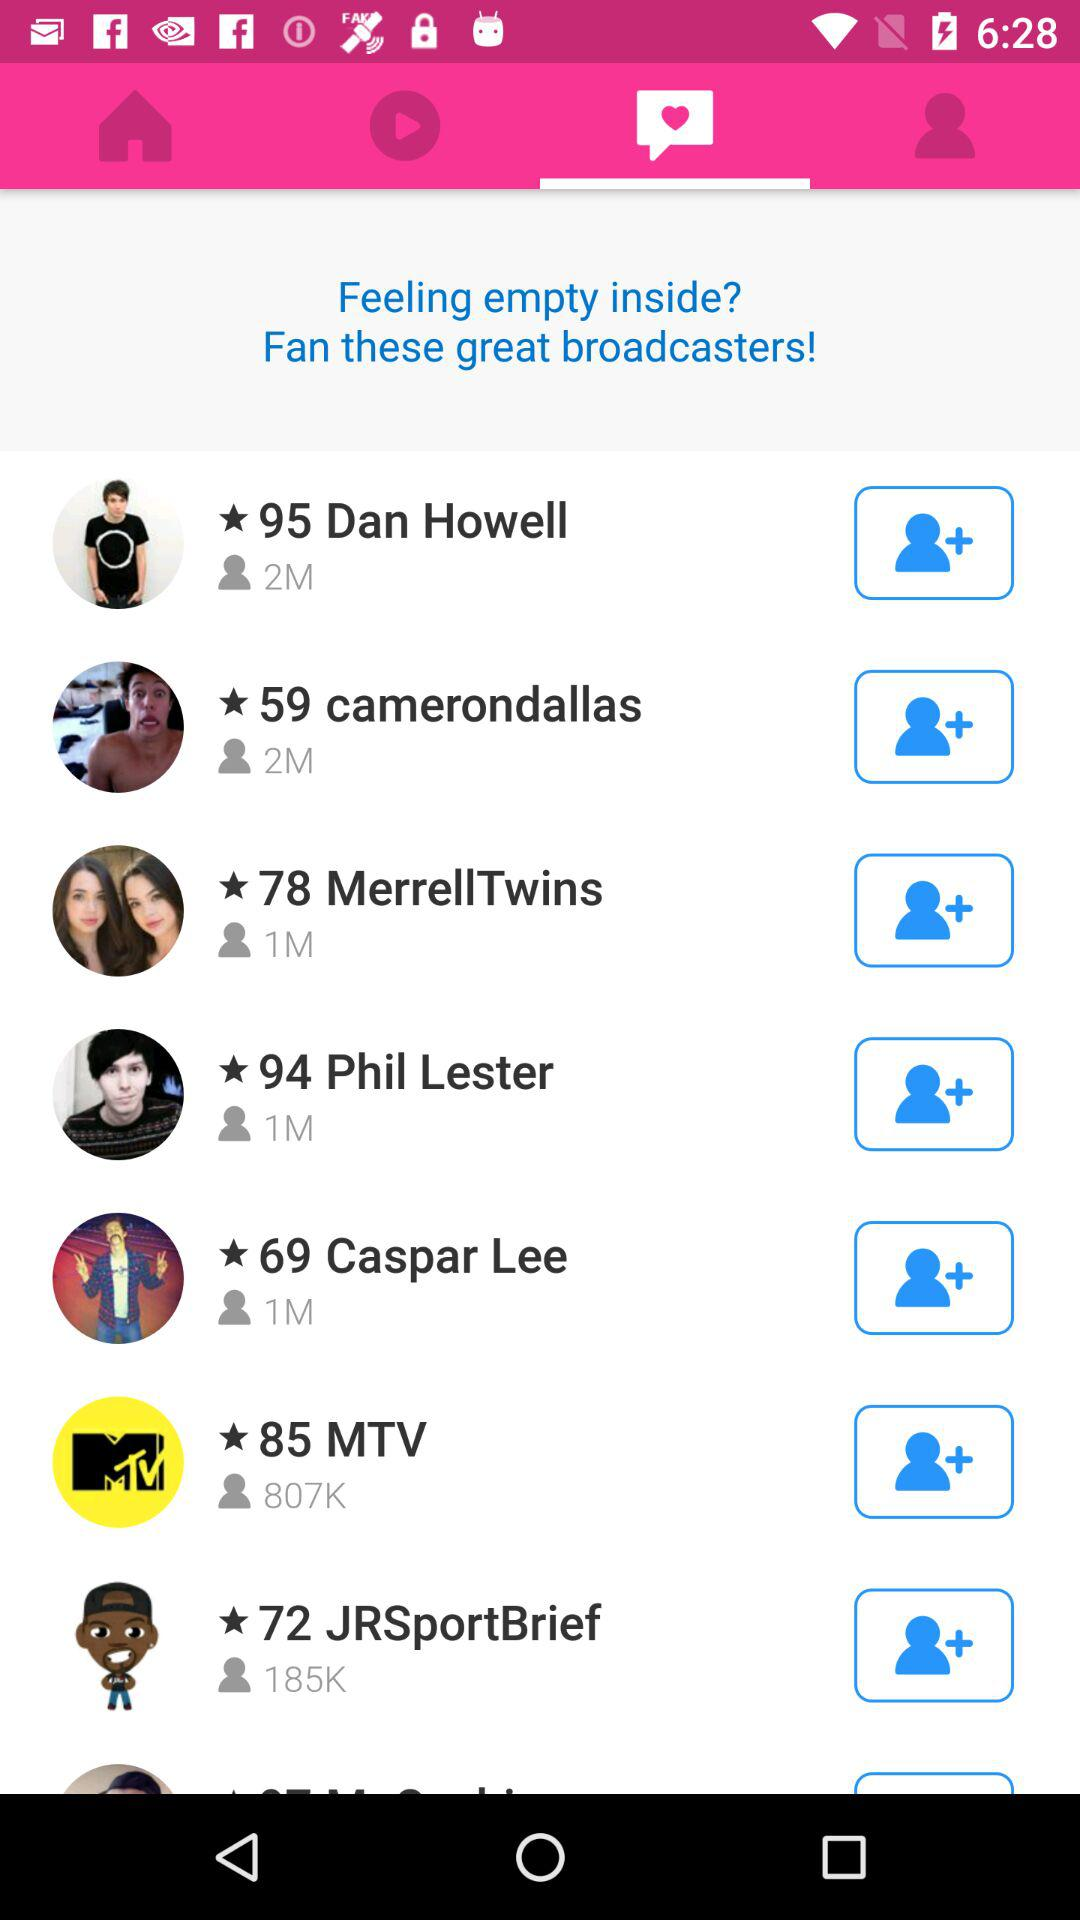How many connections does the "85 MTV" have? "85 MTV" has 807K connections. 